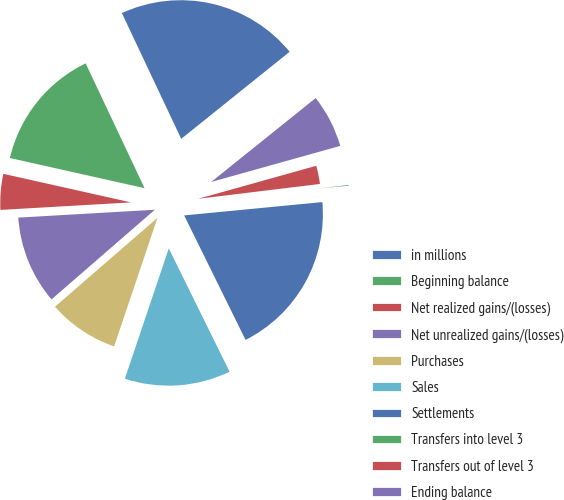Convert chart to OTSL. <chart><loc_0><loc_0><loc_500><loc_500><pie_chart><fcel>in millions<fcel>Beginning balance<fcel>Net realized gains/(losses)<fcel>Net unrealized gains/(losses)<fcel>Purchases<fcel>Sales<fcel>Settlements<fcel>Transfers into level 3<fcel>Transfers out of level 3<fcel>Ending balance<nl><fcel>21.25%<fcel>14.48%<fcel>4.42%<fcel>10.46%<fcel>8.45%<fcel>12.47%<fcel>19.24%<fcel>0.4%<fcel>2.41%<fcel>6.43%<nl></chart> 